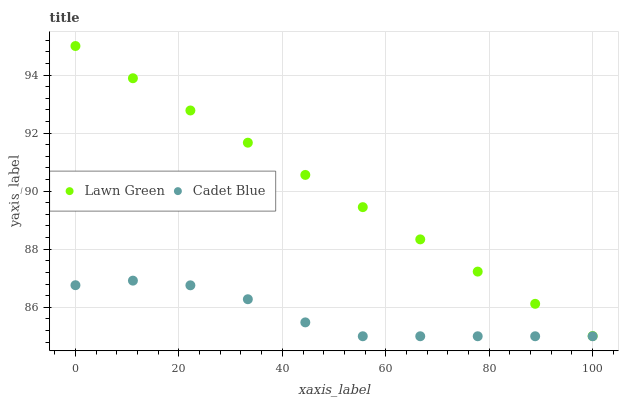Does Cadet Blue have the minimum area under the curve?
Answer yes or no. Yes. Does Lawn Green have the maximum area under the curve?
Answer yes or no. Yes. Does Cadet Blue have the maximum area under the curve?
Answer yes or no. No. Is Lawn Green the smoothest?
Answer yes or no. Yes. Is Cadet Blue the roughest?
Answer yes or no. Yes. Is Cadet Blue the smoothest?
Answer yes or no. No. Does Cadet Blue have the lowest value?
Answer yes or no. Yes. Does Lawn Green have the highest value?
Answer yes or no. Yes. Does Cadet Blue have the highest value?
Answer yes or no. No. Is Cadet Blue less than Lawn Green?
Answer yes or no. Yes. Is Lawn Green greater than Cadet Blue?
Answer yes or no. Yes. Does Cadet Blue intersect Lawn Green?
Answer yes or no. No. 